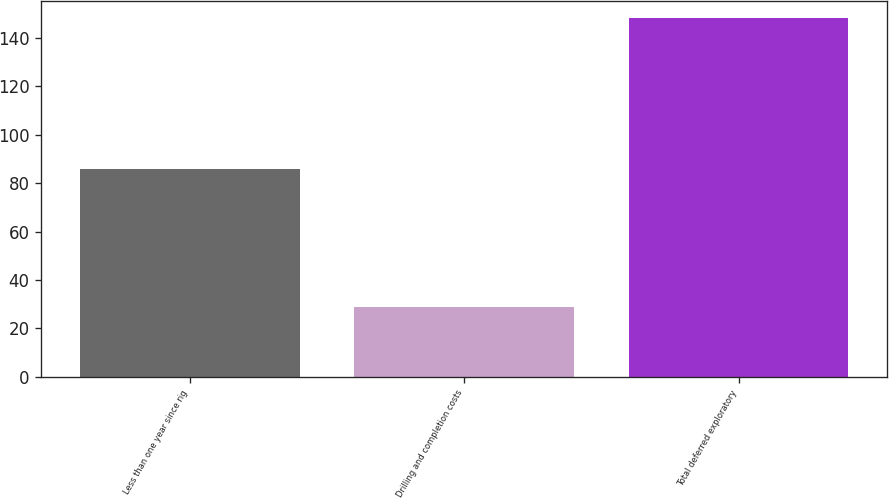Convert chart. <chart><loc_0><loc_0><loc_500><loc_500><bar_chart><fcel>Less than one year since rig<fcel>Drilling and completion costs<fcel>Total deferred exploratory<nl><fcel>86<fcel>29<fcel>148<nl></chart> 